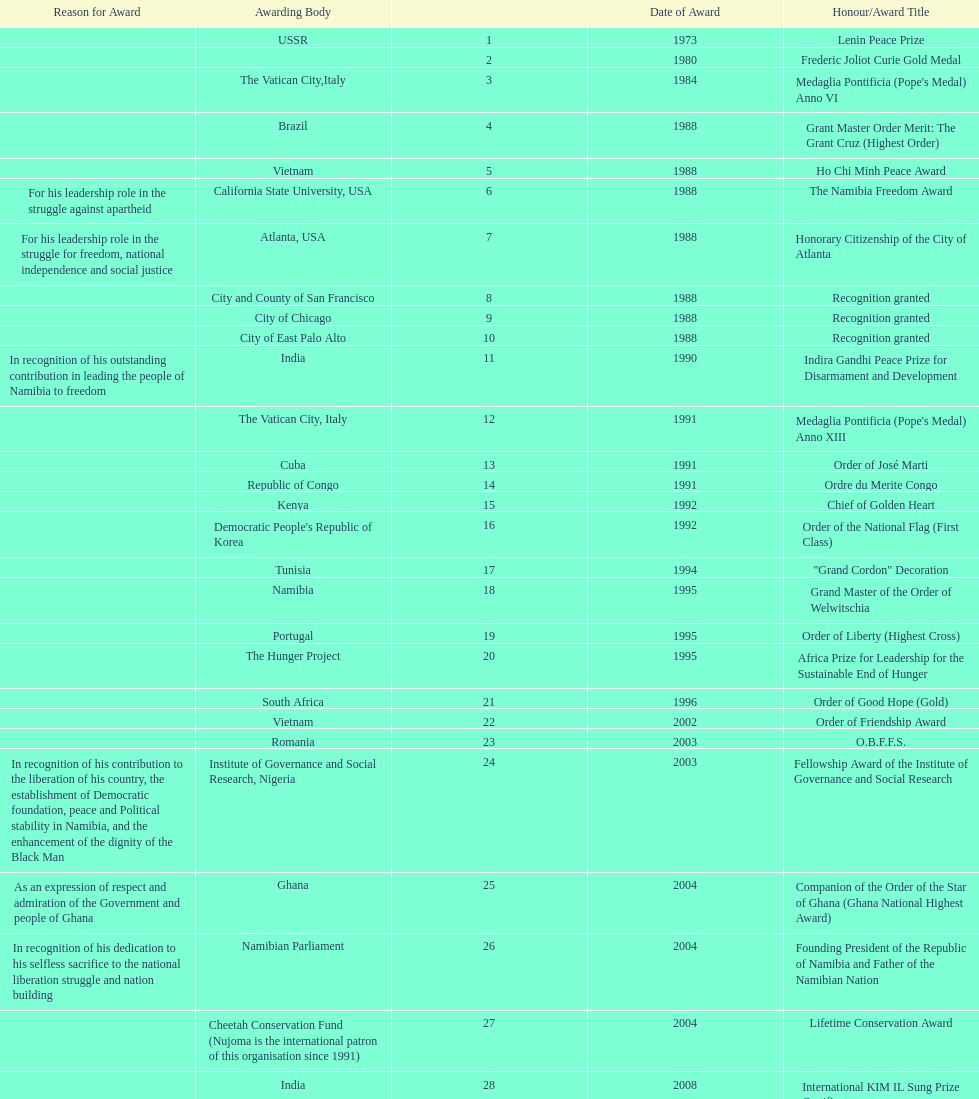Which year was the most honors/award titles given? 1988. 